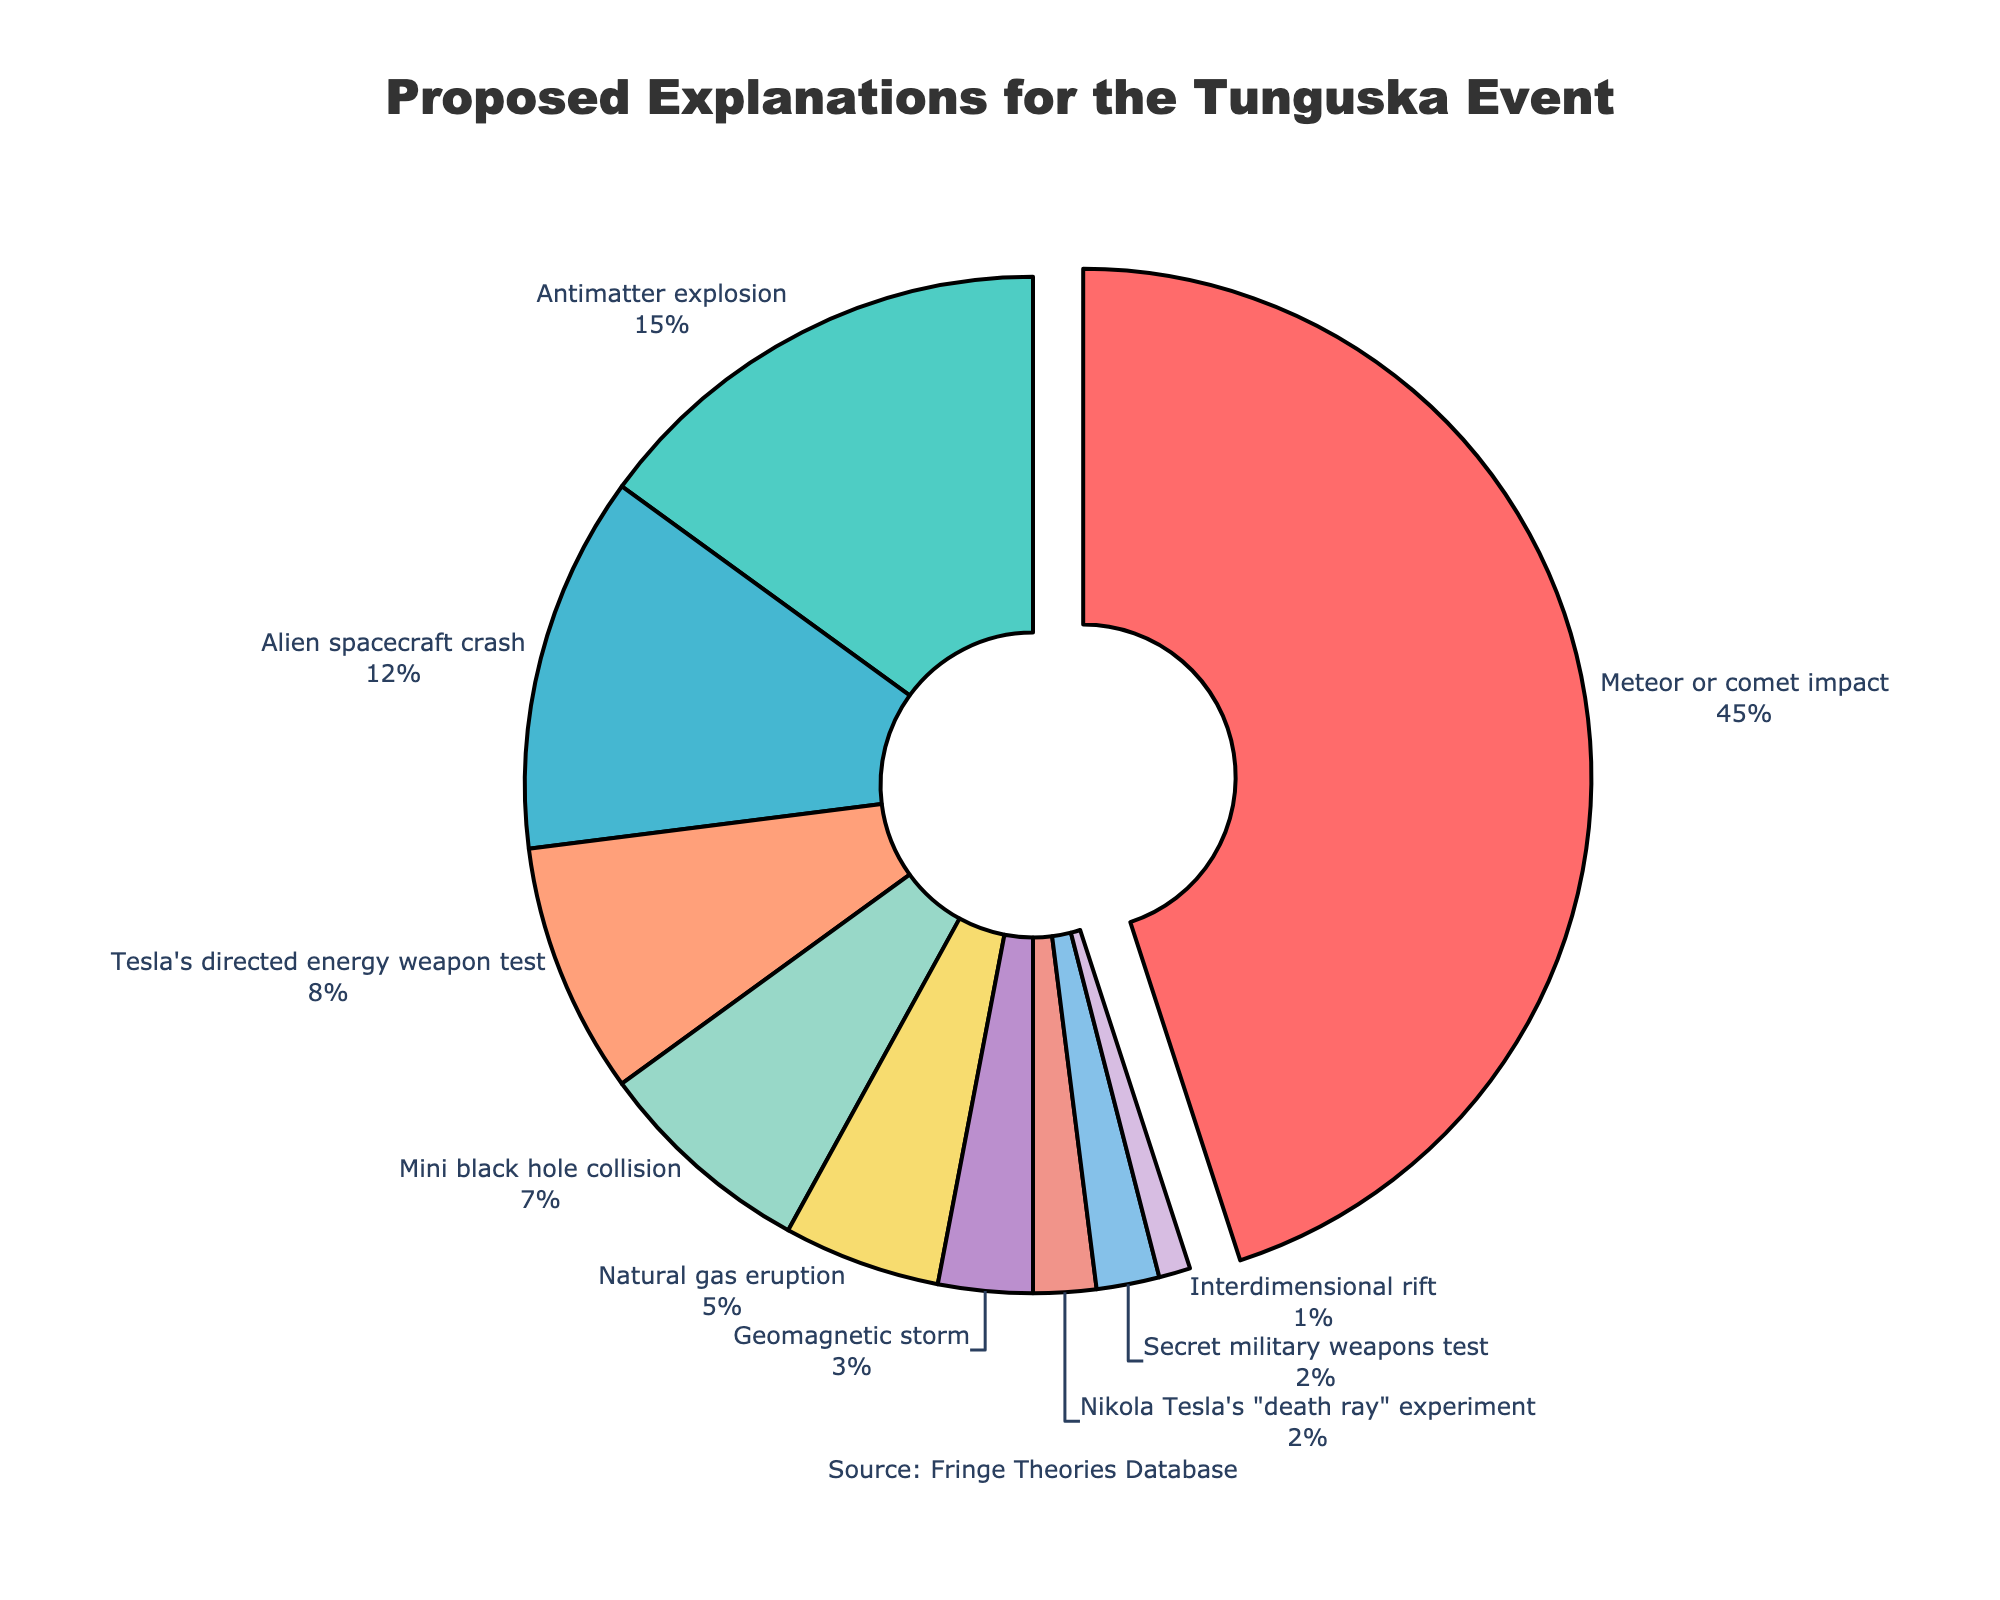What is the most proposed explanation for the Tunguska event? Observe the pie chart and identify the slice with the largest percentage label. The "Meteor or comet impact" section has the highest percentage at 45%.
Answer: Meteor or comet impact How many explanations account for more than 10% each of the total proposed explanations? Look at the pie chart and count the slices with percentages greater than 10%. "Meteor or comet impact" (45%), "Antimatter explosion" (15%), and "Alien spacecraft crash" (12%) meet this criterion.
Answer: 3 Combine the percentages of Tesla's directed energy weapon test, natural gas eruption, and geomagnetic storm. What is the total? Sum the percentages for these explanations: 8% (Tesla's directed energy weapon test) + 5% (natural gas eruption) + 3% (geomagnetic storm).
Answer: 16% Which explanation has a greater percentage, antimatter explosion or mini black hole collision? Compare the percentages of the "Antimatter explosion" (15%) and "Mini black hole collision" (7%). The "Antimatter explosion" has a greater percentage.
Answer: Antimatter explosion What percentage of the proposed explanations are attributed to human-related experiments or tests (Tesla's directed energy weapon test, Tesla's death ray experiment, secret military weapons test)? Sum the relevant percentages: Tesla's directed energy weapon test (8%) + Tesla's death ray experiment (2%) + Secret military weapons test (2%).
Answer: 12% Which explanation is represented by the purple slice in the pie chart? The visual attributes of the pie chart indicate that the purple slice corresponds to "Mini black hole collision".
Answer: Mini black hole collision Is the natural gas eruption explanation more popular than the geomagnetic storm explanation? Compare the percentages of "Natural gas eruption" (5%) and "Geomagnetic storm" (3%). "Natural gas eruption" has a higher percentage.
Answer: Yes If you combine the percentages of interdimensional rift and alien spacecraft crash, what is their total percentage? Sum the percentages: Interdimensional rift (1%) + Alien spacecraft crash (12%).
Answer: 13% How does the proportion of belief in Tesla's directed energy weapon test compare with that of the antimatter explosion theory? Compare the percentages of "Tesla's directed energy weapon test" (8%) and "Antimatter explosion" (15%). The antimatter explosion theory has a higher percentage.
Answer: Antimatter explosion is higher What is the combined percentage of the three least proposed explanations? Identify the three explanations with the smallest percentages and sum them: Interdimensional rift (1%) + Nikola Tesla's death ray experiment (2%) + Secret military weapons test (2%).
Answer: 5% 